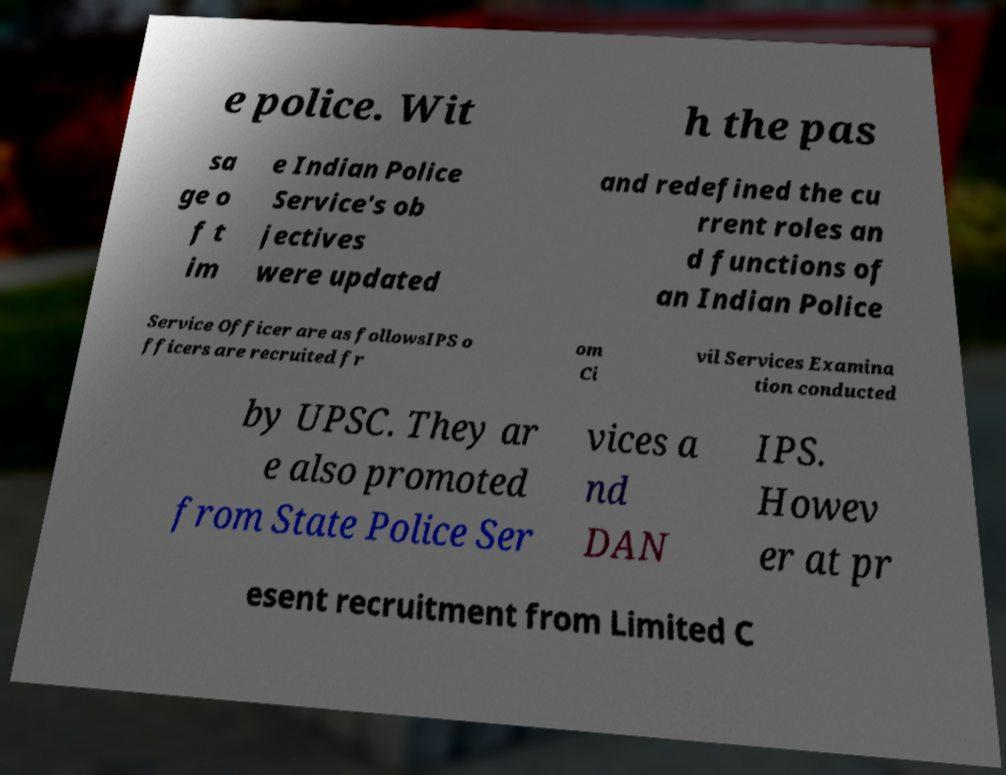Please read and relay the text visible in this image. What does it say? e police. Wit h the pas sa ge o f t im e Indian Police Service's ob jectives were updated and redefined the cu rrent roles an d functions of an Indian Police Service Officer are as followsIPS o fficers are recruited fr om Ci vil Services Examina tion conducted by UPSC. They ar e also promoted from State Police Ser vices a nd DAN IPS. Howev er at pr esent recruitment from Limited C 